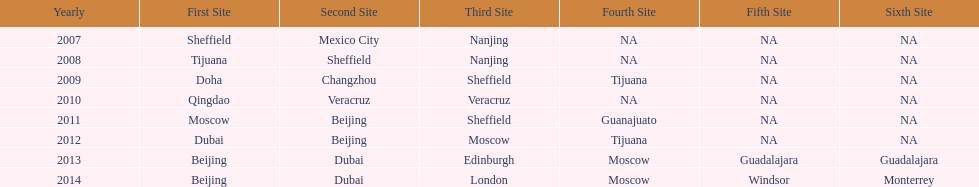In list of venues, how many years was beijing above moscow (1st venue is above 2nd venue, etc)? 3. 